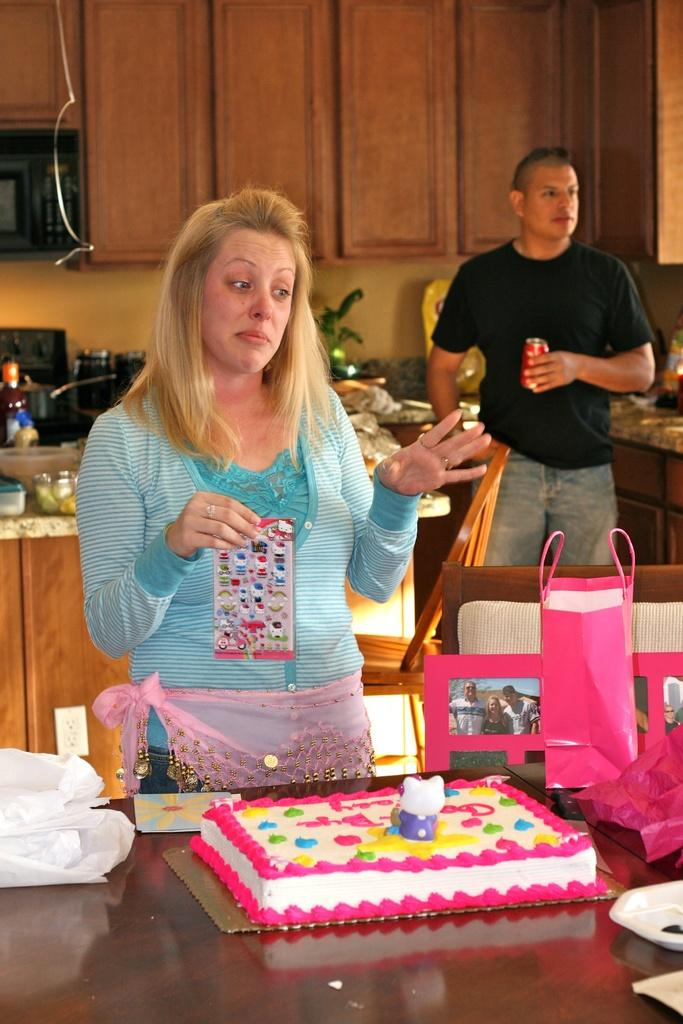How many people are in the image? There are two persons in the image. What can be seen in the image besides the people? There are tables in the image. What is on one of the tables? There is a cake on one of the tables. What else is on one of the tables? There is a bag on one of the tables. What type of cart is being used to transport the cake in the image? There is no cart present in the image; the cake is on a table. 